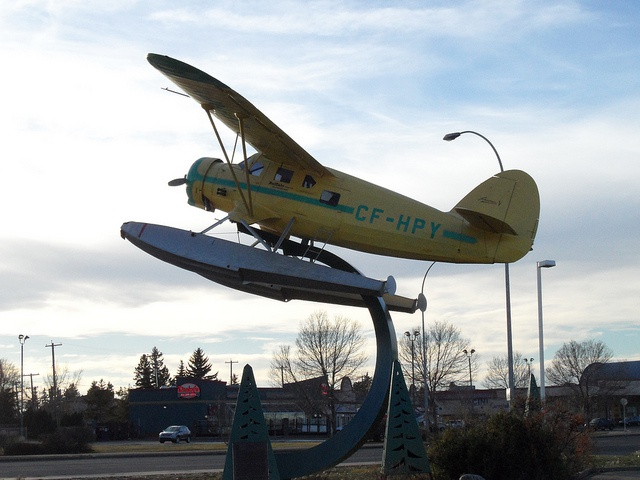Describe the objects in this image and their specific colors. I can see airplane in white, black, darkgreen, gray, and blue tones, car in white, black, blue, gray, and navy tones, car in white, black, purple, and darkblue tones, and car in white, black, and gray tones in this image. 